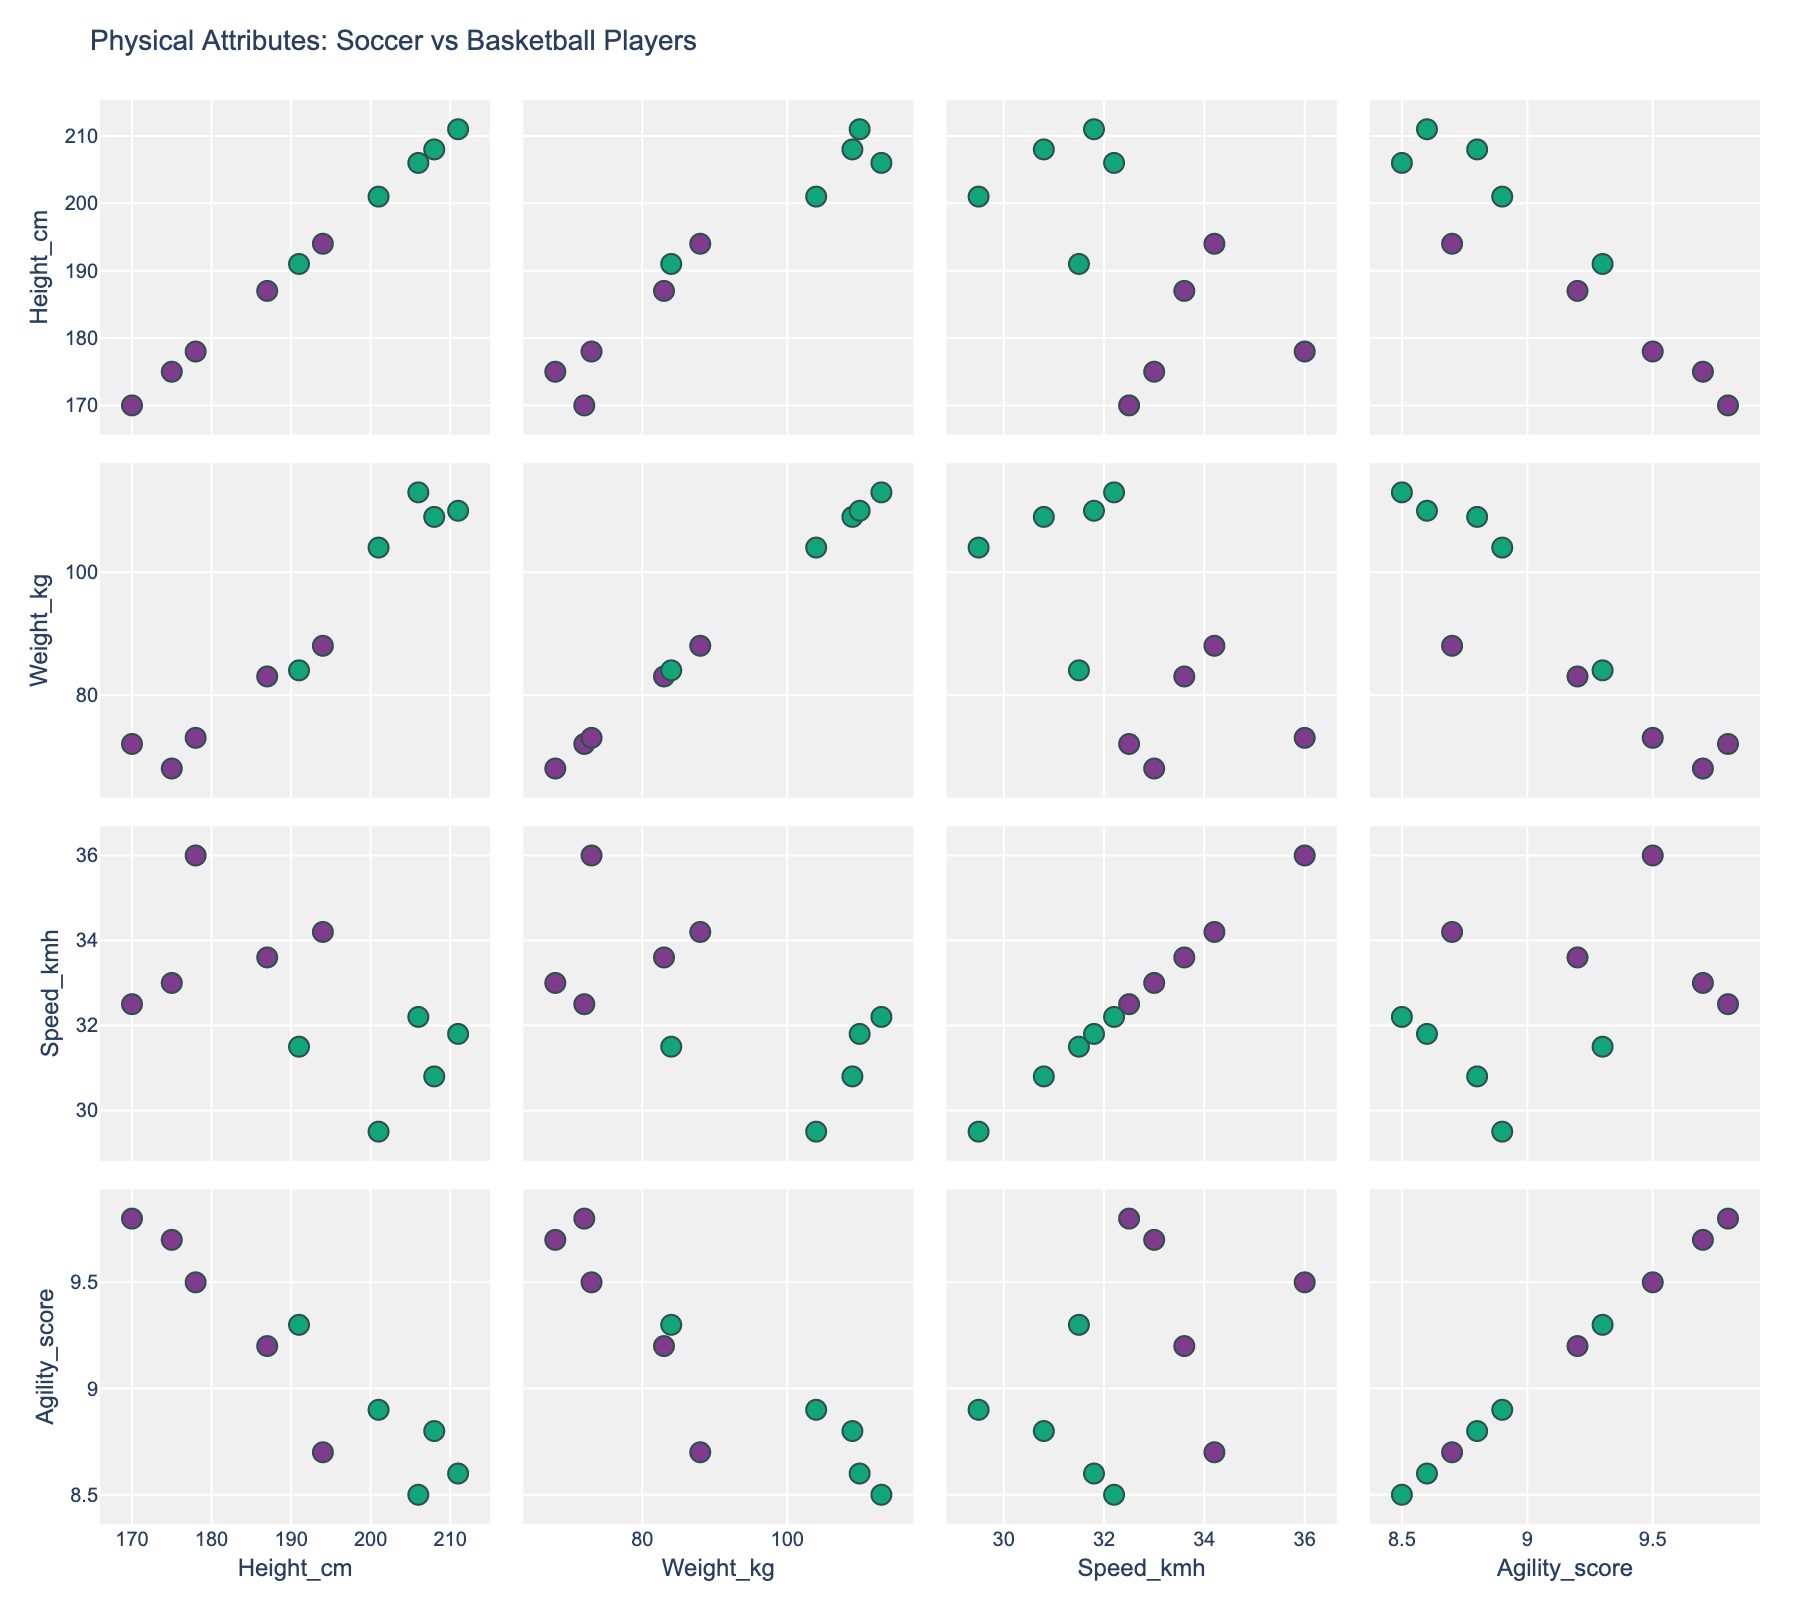What is the title of the figure? The title of the figure is generally displayed at the top of the plot. It is directly visible and usually describes the main focus of the figure.
Answer: Physical Attributes: Soccer vs Basketball Players How many attributes (variables) are compared in the scatterplot matrix? The scatterplot matrix compares multiple attributes based on the number of rows and columns. Each attribute represents a different combination of numeric data. In this case, the matrix has 4 rows and 4 columns.
Answer: 4 Which sport generally has taller players, soccer or basketball? By observing the scatterplots involving the Height_cm attribute, the data points for Basketball players (in a distinct color) appear higher on the y-axis compared to Soccer players.
Answer: Basketball Are there any soccer players who are taller than some basketball players? Check the data points for soccer within the scatterplot involving Height_cm and compare them to the lowest data points for basketball players. For instance, compare someone like Erling Haaland (194 cm) with the shortest basketball player, such as Stephen Curry (191 cm).
Answer: Yes Which soccer player has the highest speed? In the scatterplot where Speed_kmh is on the y-axis, look for the highest point among the data points colored to represent soccer players. The player with the highest y-coordinate value is Kylian Mbappé (36.0 km/h).
Answer: Kylian Mbappé Is there a strong correlation between height and weight among basketball players? Observe the scatterplot where Height_cm is on the x-axis and Weight_kg is on the y-axis. Look for the pattern and clustering of data points specific to basketball players, represented by their unique color. A strong linear pattern indicates a strong correlation.
Answer: Yes On average, who has greater agility scores, soccer or basketball players? To find the average agility score, look at the Agility_score axis for both sports, and visually analyze the clustering of data points. Soccer players generally seem to have higher Agility_score values based on their closer proximity to higher scores.
Answer: Soccer players Compare Stephen Curry’s speed to Lionel Messi’s speed. Who is faster? Locate Stephen Curry and Lionel Messi data points in the plot with Speed_kmh on the y-axis. Compare their vertical positions. Stephen Curry’s speed (31.5 km/h) is less than Lionel Messi’s (32.5 km/h).
Answer: Lionel Messi Is the distribution of weights more varied within soccer players or basketball players? Scatterplots involving Weight_kg should be observed for the spread and range of the data points. A wider range and varied distribution indicate more variability. Basketball players' weights range more significantly indicating more variance.
Answer: Basketball players Who is the player with the highest agility score and which sport do they play? Check the scatterplot for the highest vertical data point along the Agility_score axis. Neymar Jr., with an agility score of 9.8, has the highest score, and he plays soccer.
Answer: Neymar Jr., Soccer 